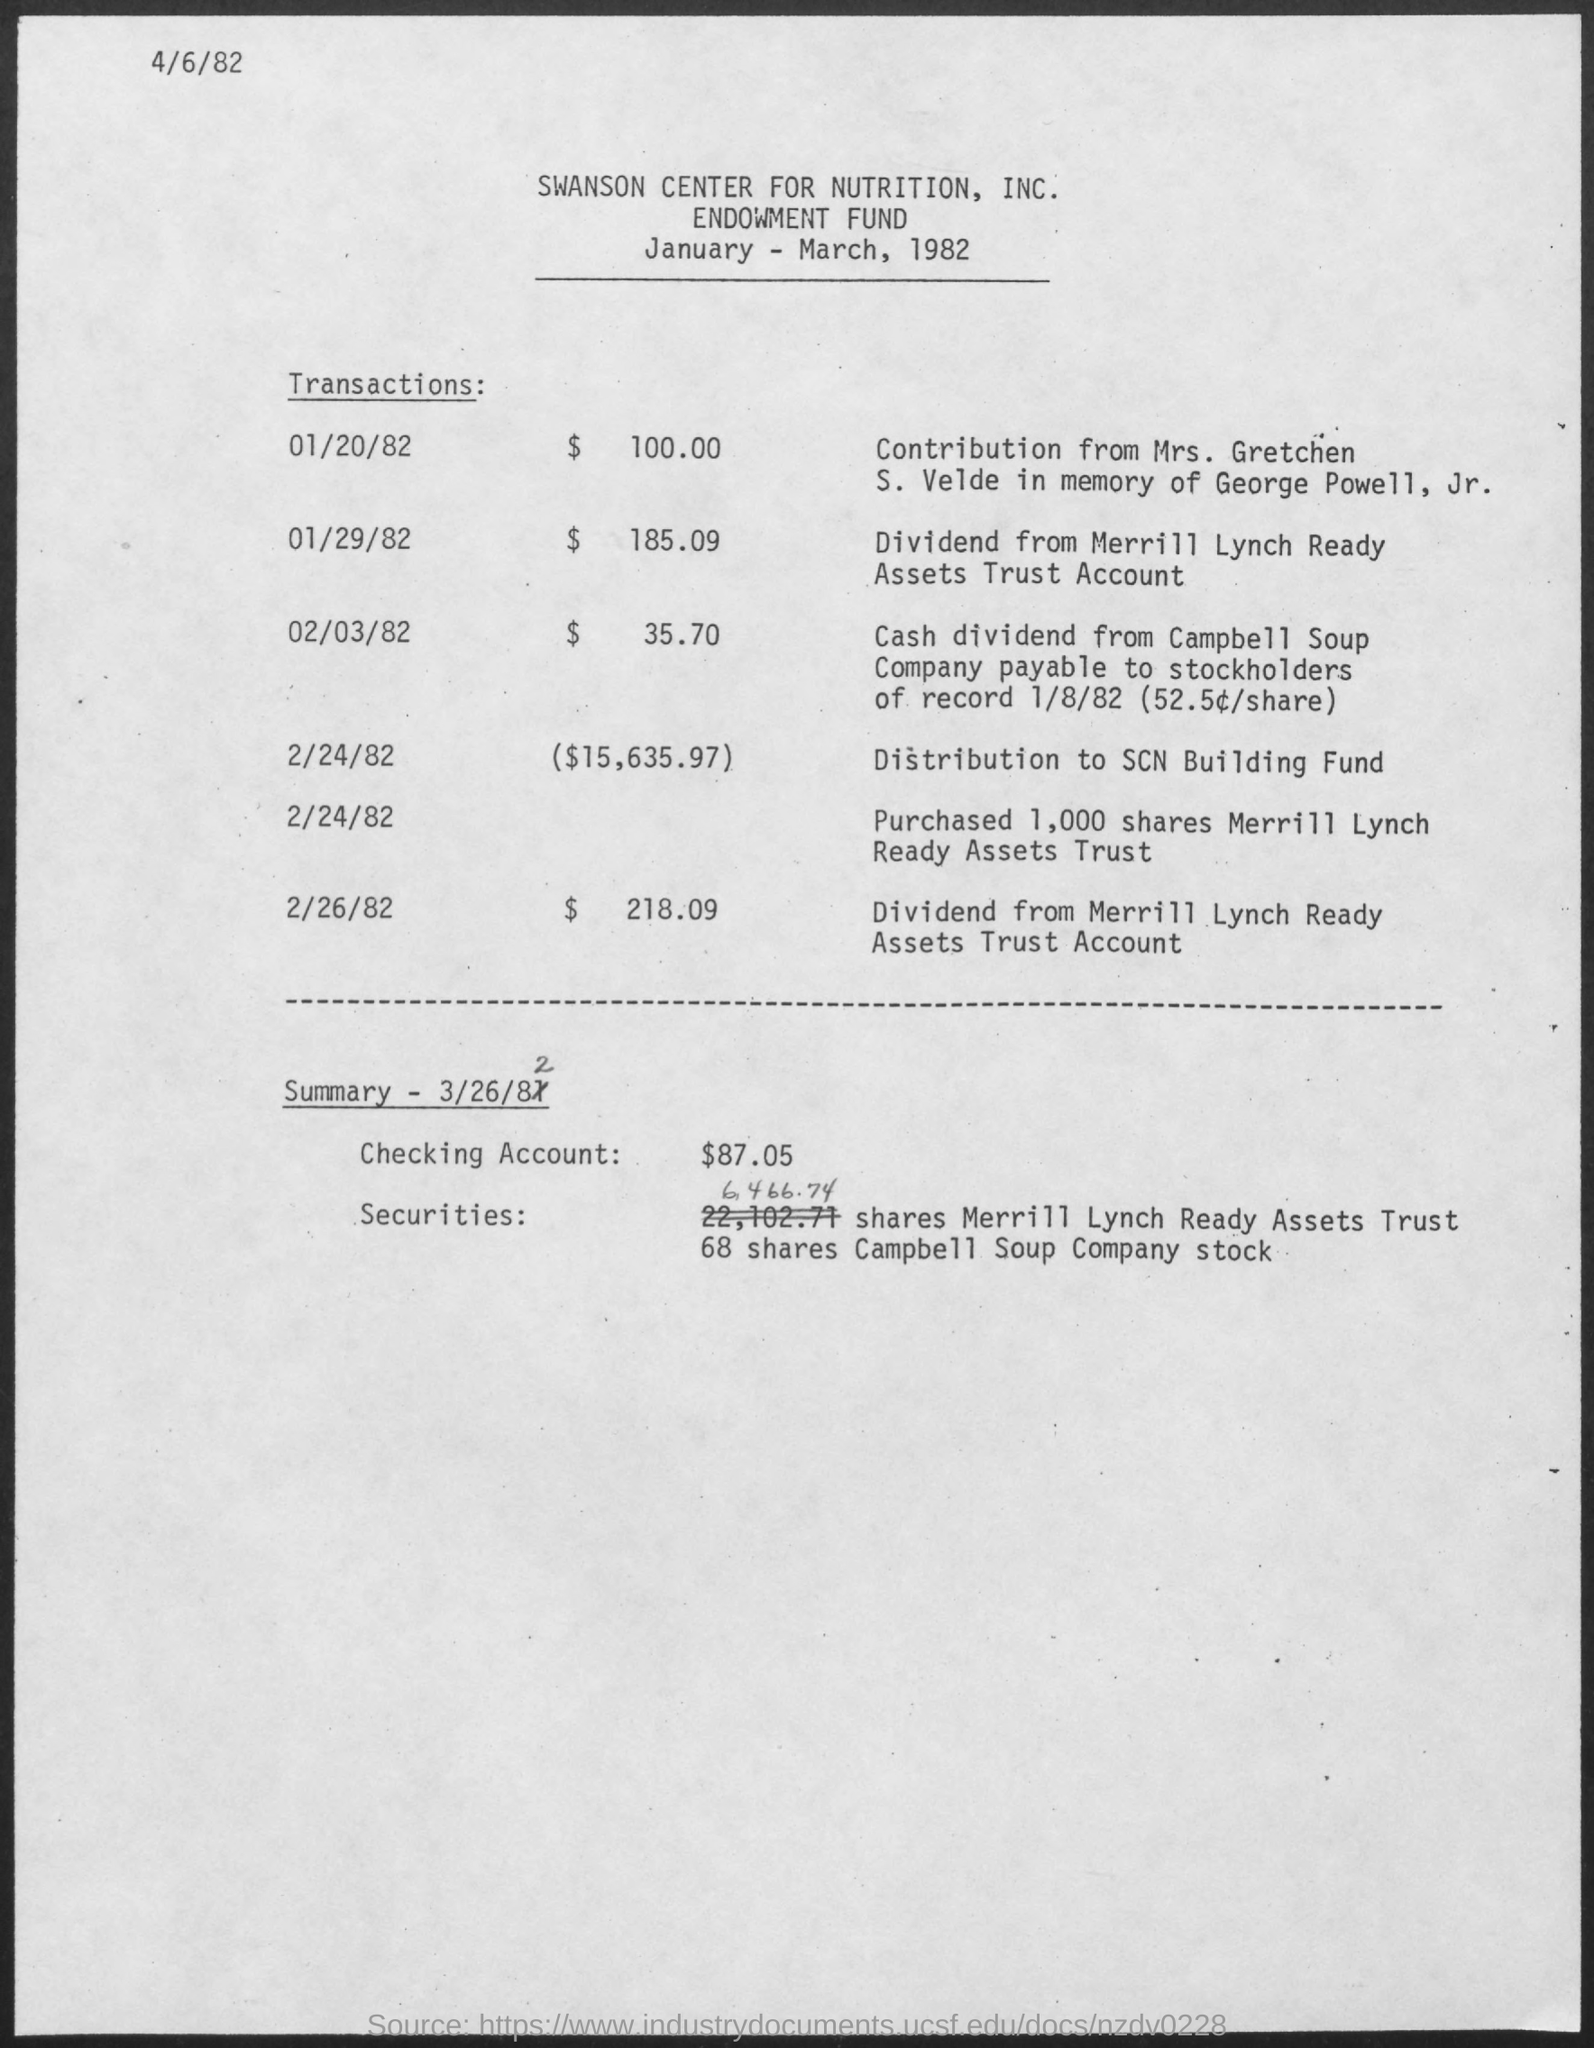List a handful of essential elements in this visual. On February 26th, 1982, the transaction amount was $218.09. The date of March 26, 1982, is? On February 3, 1982, the transaction amount was $35.70. On January 29, 1982, the transaction amount was $185.09. On January 20, 1982, the transaction amount was $100.00. 